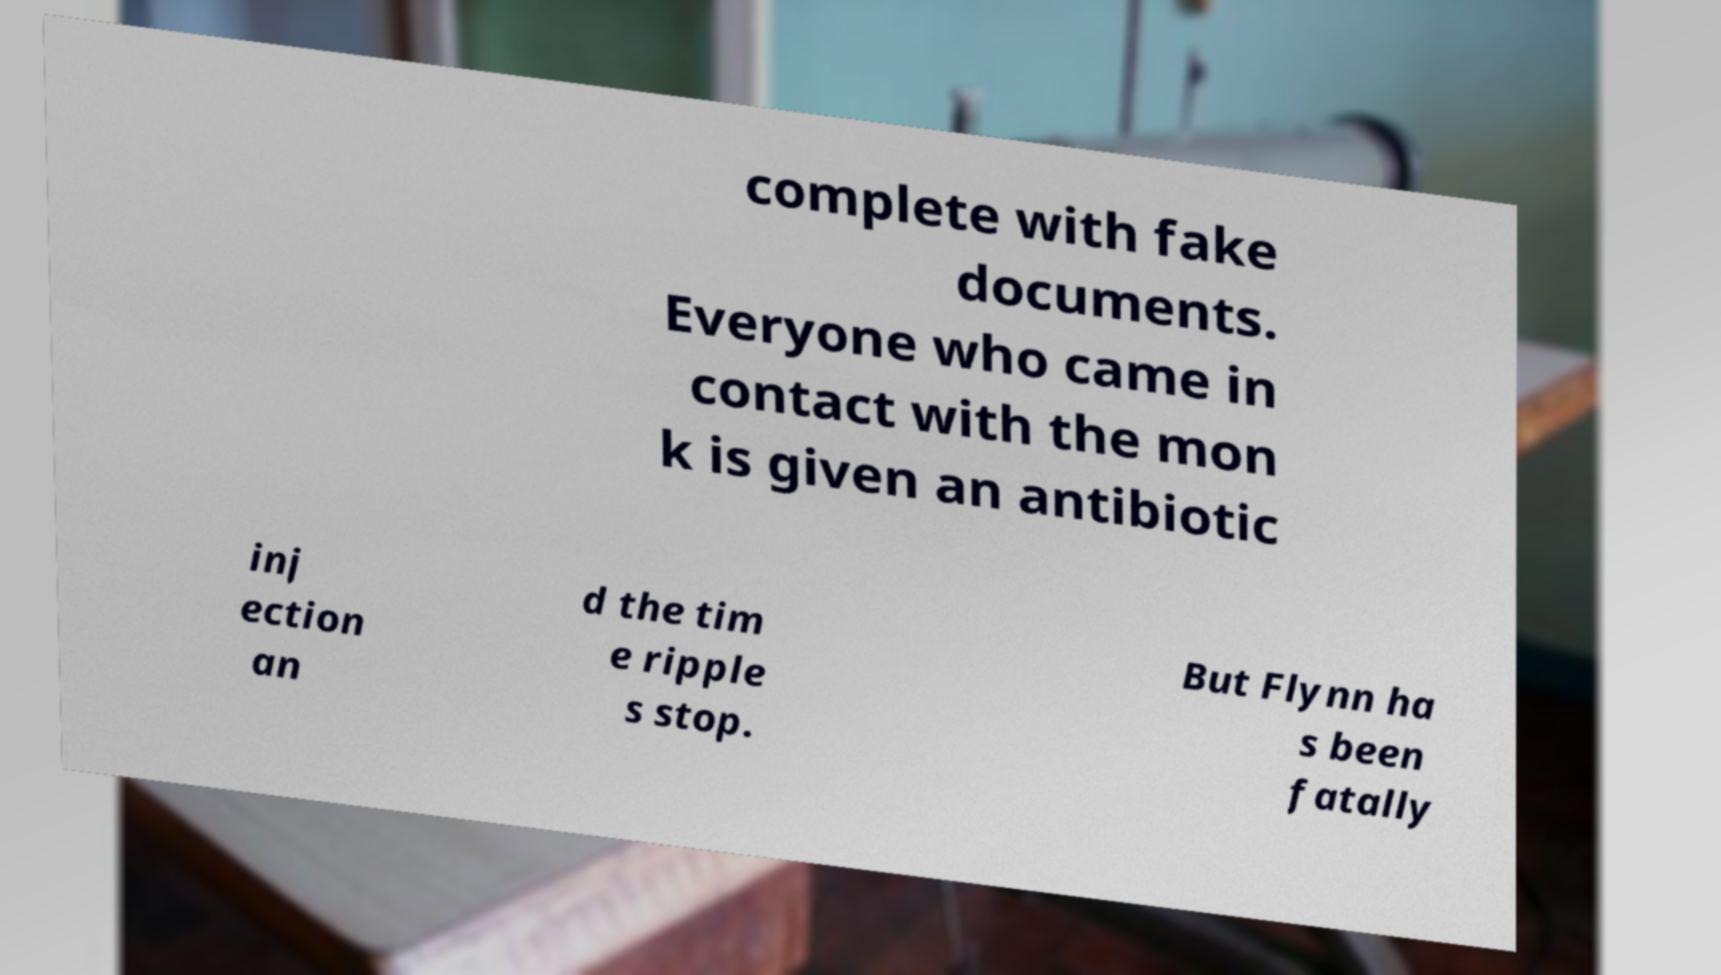For documentation purposes, I need the text within this image transcribed. Could you provide that? complete with fake documents. Everyone who came in contact with the mon k is given an antibiotic inj ection an d the tim e ripple s stop. But Flynn ha s been fatally 